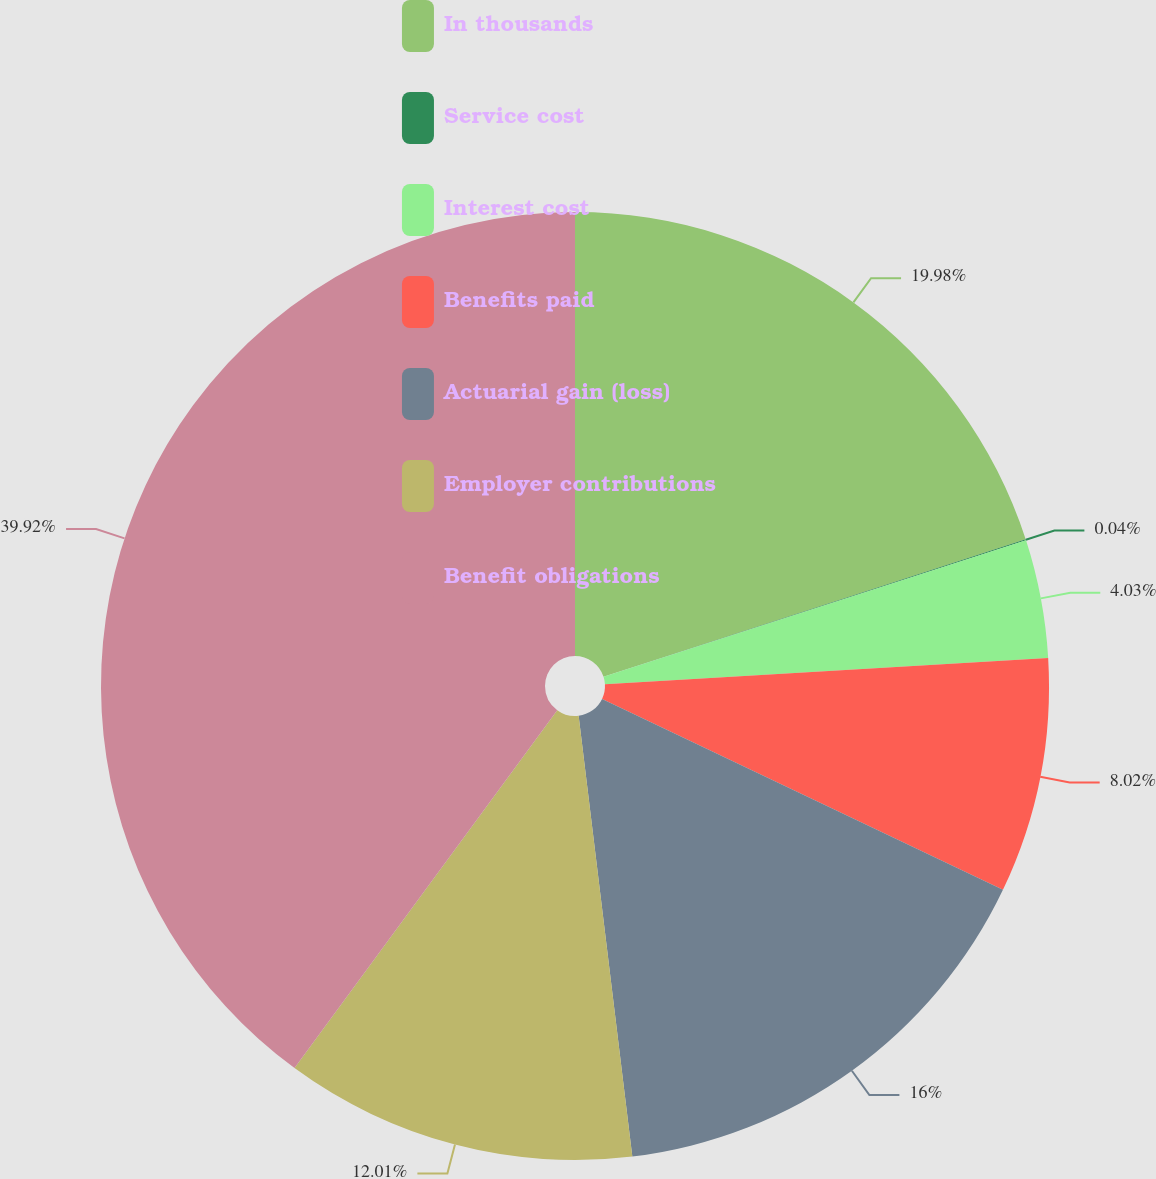Convert chart to OTSL. <chart><loc_0><loc_0><loc_500><loc_500><pie_chart><fcel>In thousands<fcel>Service cost<fcel>Interest cost<fcel>Benefits paid<fcel>Actuarial gain (loss)<fcel>Employer contributions<fcel>Benefit obligations<nl><fcel>19.99%<fcel>0.04%<fcel>4.03%<fcel>8.02%<fcel>16.0%<fcel>12.01%<fcel>39.93%<nl></chart> 